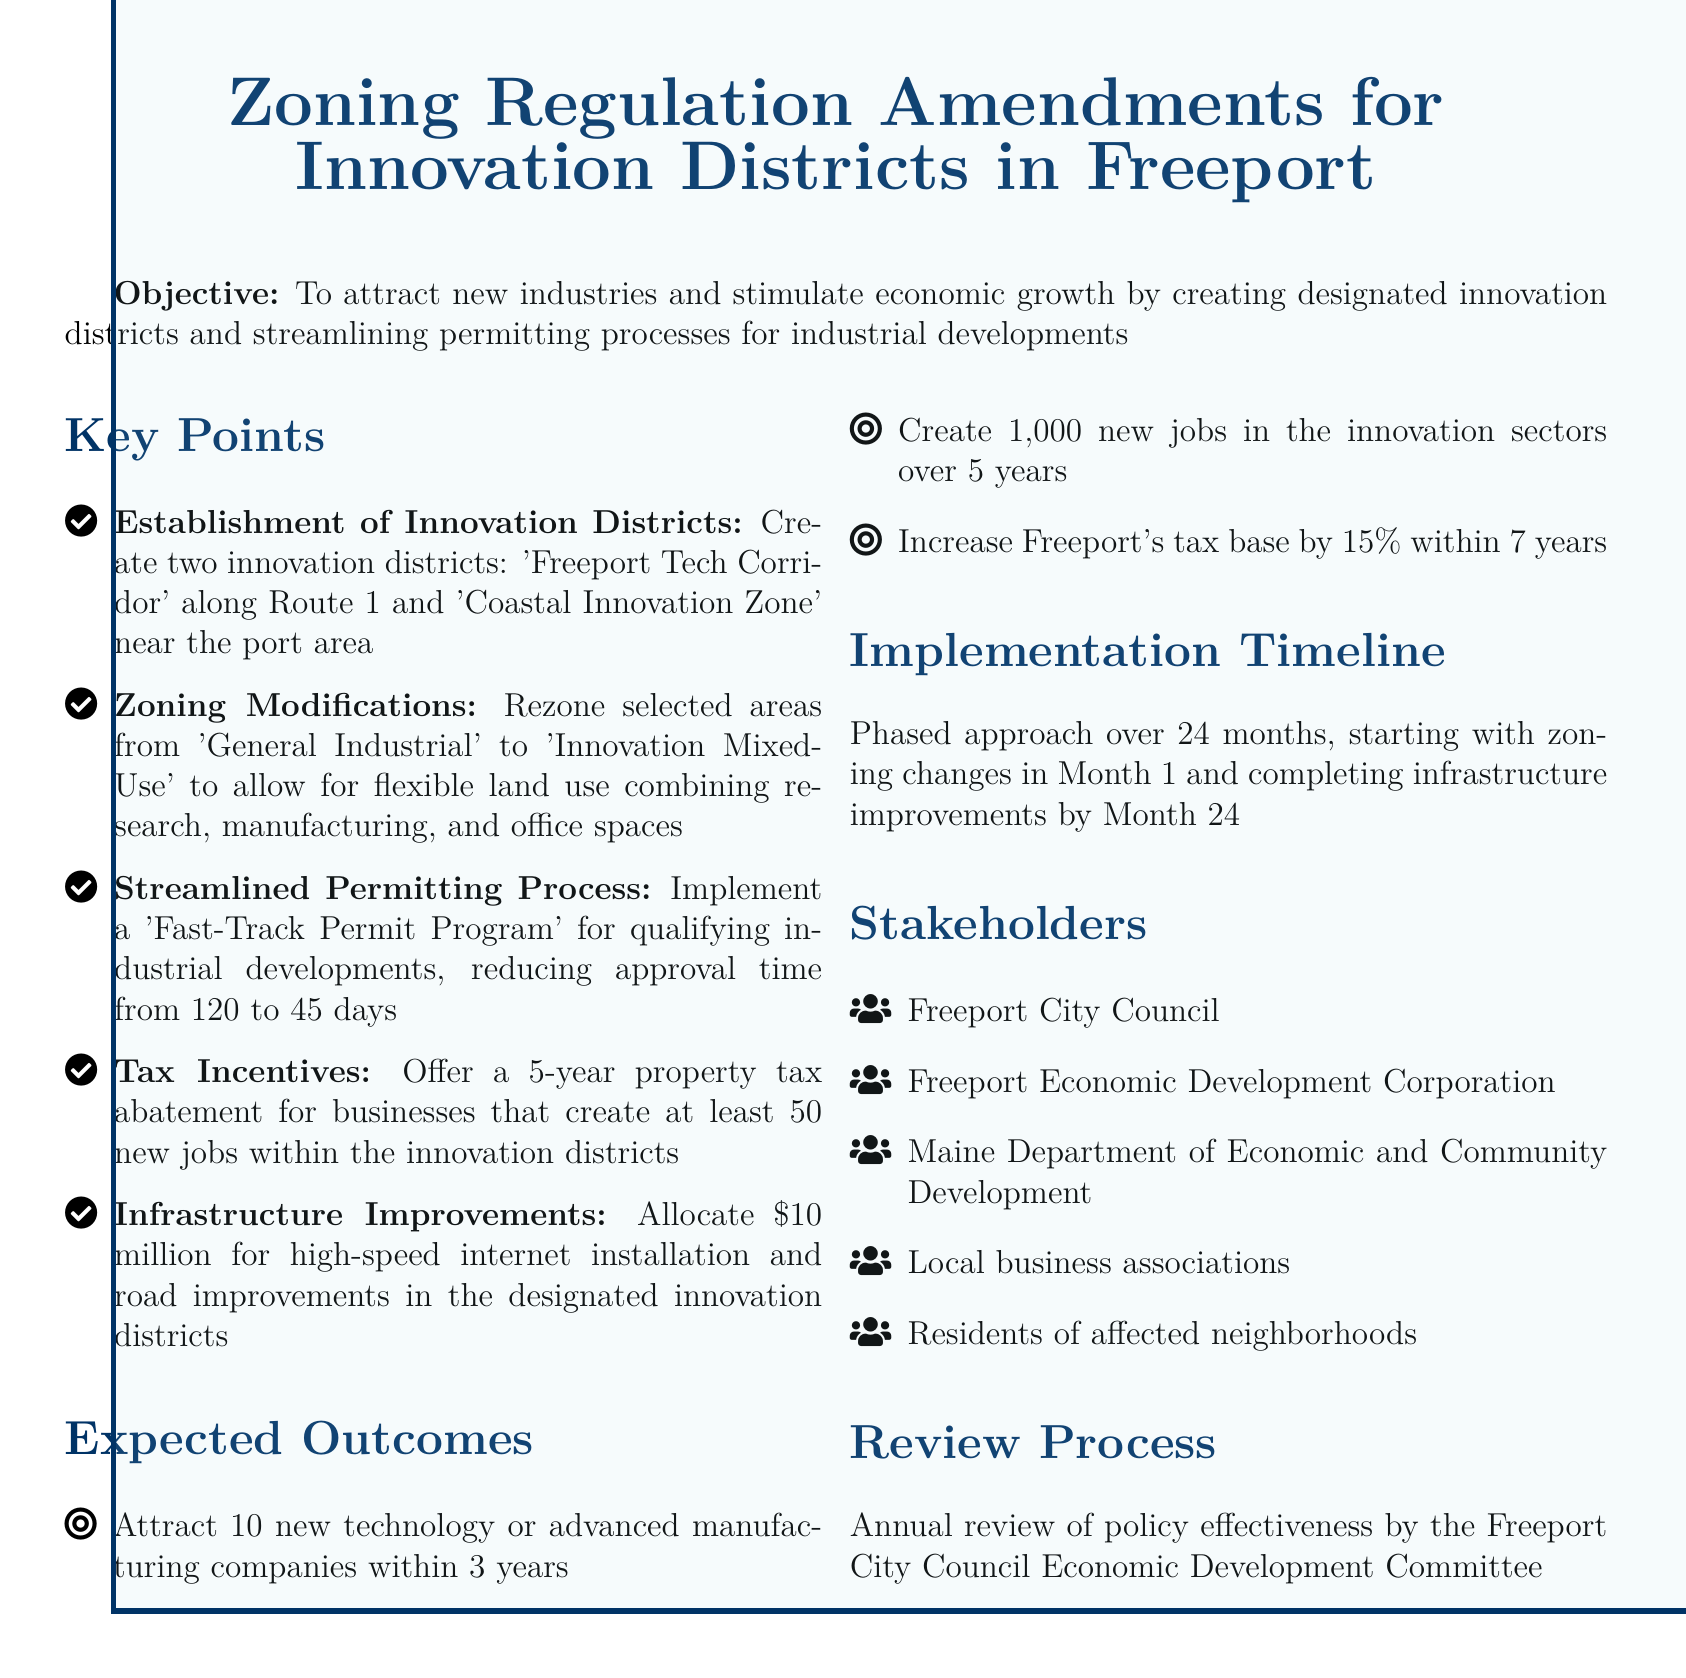what are the names of the designated innovation districts? The document lists two designated innovation districts: the 'Freeport Tech Corridor' and the 'Coastal Innovation Zone.'
Answer: Freeport Tech Corridor, Coastal Innovation Zone what is the timeline for the implementation of the policy? The implementation of the policy is planned as a phased approach over 24 months, starting with zoning changes in Month 1.
Answer: 24 months how many new jobs are expected to be created in innovation sectors? The document states that the goal is to create 1,000 new jobs in innovation sectors over 5 years.
Answer: 1,000 new jobs what is the property tax incentive for qualifying businesses? Businesses that create at least 50 new jobs within the innovation districts are offered a 5-year property tax abatement.
Answer: 5-year property tax abatement what is the purpose of the Fast-Track Permit Program? The Fast-Track Permit Program aims to expedite the permitting process for qualifying industrial developments, reducing approval time significantly.
Answer: Reduce approval time to 45 days how much funding is allocated for infrastructure improvements? The document specifies that $10 million is allocated for high-speed internet installation and road improvements.
Answer: $10 million what percentage increase in the tax base is expected within 7 years? The expected increase in Freeport's tax base is stated to be 15% within 7 years.
Answer: 15% who is responsible for the annual review of policy effectiveness? The annual review of policy effectiveness is conducted by the Freeport City Council Economic Development Committee.
Answer: Freeport City Council Economic Development Committee 